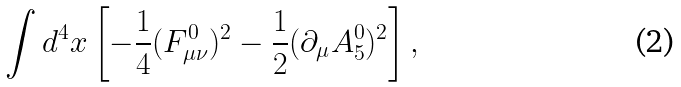<formula> <loc_0><loc_0><loc_500><loc_500>\int d ^ { 4 } x \left [ - \frac { 1 } { 4 } ( F ^ { 0 } _ { \mu \nu } ) ^ { 2 } - \frac { 1 } { 2 } ( \partial _ { \mu } A ^ { 0 } _ { 5 } ) ^ { 2 } \right ] ,</formula> 